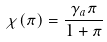<formula> <loc_0><loc_0><loc_500><loc_500>\chi ( \pi ) = \frac { \gamma _ { a } \pi } { 1 + \pi }</formula> 